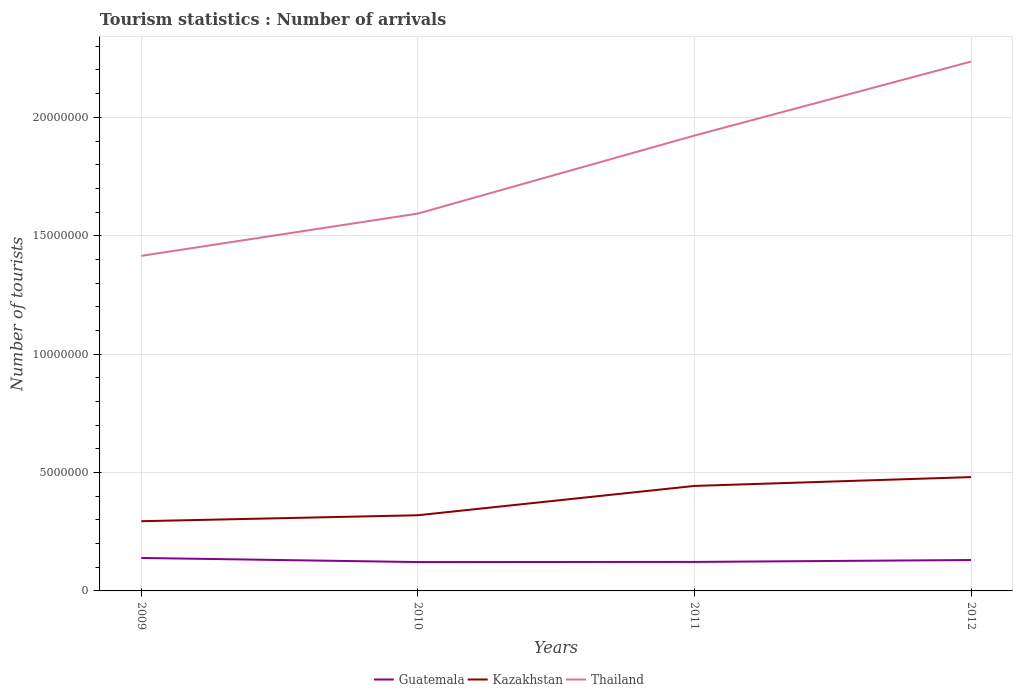How many different coloured lines are there?
Ensure brevity in your answer.  3. Is the number of lines equal to the number of legend labels?
Your answer should be very brief. Yes. Across all years, what is the maximum number of tourist arrivals in Kazakhstan?
Offer a terse response. 2.94e+06. What is the total number of tourist arrivals in Guatemala in the graph?
Provide a succinct answer. -6000. What is the difference between the highest and the second highest number of tourist arrivals in Guatemala?
Ensure brevity in your answer.  1.73e+05. What is the difference between the highest and the lowest number of tourist arrivals in Guatemala?
Your answer should be compact. 2. Is the number of tourist arrivals in Guatemala strictly greater than the number of tourist arrivals in Thailand over the years?
Your answer should be compact. Yes. How many lines are there?
Your answer should be compact. 3. What is the difference between two consecutive major ticks on the Y-axis?
Make the answer very short. 5.00e+06. Are the values on the major ticks of Y-axis written in scientific E-notation?
Your answer should be very brief. No. Does the graph contain any zero values?
Your answer should be compact. No. How many legend labels are there?
Your answer should be compact. 3. What is the title of the graph?
Provide a succinct answer. Tourism statistics : Number of arrivals. What is the label or title of the Y-axis?
Provide a succinct answer. Number of tourists. What is the Number of tourists of Guatemala in 2009?
Your response must be concise. 1.39e+06. What is the Number of tourists in Kazakhstan in 2009?
Make the answer very short. 2.94e+06. What is the Number of tourists in Thailand in 2009?
Offer a terse response. 1.42e+07. What is the Number of tourists of Guatemala in 2010?
Your answer should be compact. 1.22e+06. What is the Number of tourists in Kazakhstan in 2010?
Provide a succinct answer. 3.20e+06. What is the Number of tourists of Thailand in 2010?
Make the answer very short. 1.59e+07. What is the Number of tourists of Guatemala in 2011?
Your response must be concise. 1.22e+06. What is the Number of tourists of Kazakhstan in 2011?
Your answer should be compact. 4.43e+06. What is the Number of tourists in Thailand in 2011?
Your answer should be compact. 1.92e+07. What is the Number of tourists of Guatemala in 2012?
Provide a succinct answer. 1.30e+06. What is the Number of tourists of Kazakhstan in 2012?
Offer a terse response. 4.81e+06. What is the Number of tourists of Thailand in 2012?
Offer a terse response. 2.24e+07. Across all years, what is the maximum Number of tourists of Guatemala?
Offer a terse response. 1.39e+06. Across all years, what is the maximum Number of tourists of Kazakhstan?
Make the answer very short. 4.81e+06. Across all years, what is the maximum Number of tourists of Thailand?
Provide a short and direct response. 2.24e+07. Across all years, what is the minimum Number of tourists in Guatemala?
Offer a terse response. 1.22e+06. Across all years, what is the minimum Number of tourists of Kazakhstan?
Your answer should be compact. 2.94e+06. Across all years, what is the minimum Number of tourists in Thailand?
Offer a very short reply. 1.42e+07. What is the total Number of tourists of Guatemala in the graph?
Ensure brevity in your answer.  5.14e+06. What is the total Number of tourists in Kazakhstan in the graph?
Give a very brief answer. 1.54e+07. What is the total Number of tourists in Thailand in the graph?
Your answer should be very brief. 7.17e+07. What is the difference between the Number of tourists of Guatemala in 2009 and that in 2010?
Provide a short and direct response. 1.73e+05. What is the difference between the Number of tourists in Kazakhstan in 2009 and that in 2010?
Ensure brevity in your answer.  -2.52e+05. What is the difference between the Number of tourists in Thailand in 2009 and that in 2010?
Provide a succinct answer. -1.79e+06. What is the difference between the Number of tourists in Guatemala in 2009 and that in 2011?
Ensure brevity in your answer.  1.67e+05. What is the difference between the Number of tourists in Kazakhstan in 2009 and that in 2011?
Give a very brief answer. -1.49e+06. What is the difference between the Number of tourists in Thailand in 2009 and that in 2011?
Provide a succinct answer. -5.08e+06. What is the difference between the Number of tourists of Guatemala in 2009 and that in 2012?
Offer a very short reply. 8.70e+04. What is the difference between the Number of tourists in Kazakhstan in 2009 and that in 2012?
Keep it short and to the point. -1.86e+06. What is the difference between the Number of tourists of Thailand in 2009 and that in 2012?
Offer a terse response. -8.20e+06. What is the difference between the Number of tourists of Guatemala in 2010 and that in 2011?
Your answer should be compact. -6000. What is the difference between the Number of tourists in Kazakhstan in 2010 and that in 2011?
Provide a succinct answer. -1.24e+06. What is the difference between the Number of tourists in Thailand in 2010 and that in 2011?
Provide a succinct answer. -3.29e+06. What is the difference between the Number of tourists in Guatemala in 2010 and that in 2012?
Make the answer very short. -8.60e+04. What is the difference between the Number of tourists in Kazakhstan in 2010 and that in 2012?
Keep it short and to the point. -1.61e+06. What is the difference between the Number of tourists in Thailand in 2010 and that in 2012?
Ensure brevity in your answer.  -6.42e+06. What is the difference between the Number of tourists of Kazakhstan in 2011 and that in 2012?
Your answer should be compact. -3.73e+05. What is the difference between the Number of tourists in Thailand in 2011 and that in 2012?
Your response must be concise. -3.12e+06. What is the difference between the Number of tourists of Guatemala in 2009 and the Number of tourists of Kazakhstan in 2010?
Your response must be concise. -1.80e+06. What is the difference between the Number of tourists of Guatemala in 2009 and the Number of tourists of Thailand in 2010?
Provide a succinct answer. -1.45e+07. What is the difference between the Number of tourists in Kazakhstan in 2009 and the Number of tourists in Thailand in 2010?
Ensure brevity in your answer.  -1.30e+07. What is the difference between the Number of tourists of Guatemala in 2009 and the Number of tourists of Kazakhstan in 2011?
Give a very brief answer. -3.04e+06. What is the difference between the Number of tourists in Guatemala in 2009 and the Number of tourists in Thailand in 2011?
Your answer should be very brief. -1.78e+07. What is the difference between the Number of tourists in Kazakhstan in 2009 and the Number of tourists in Thailand in 2011?
Your answer should be very brief. -1.63e+07. What is the difference between the Number of tourists of Guatemala in 2009 and the Number of tourists of Kazakhstan in 2012?
Offer a very short reply. -3.42e+06. What is the difference between the Number of tourists in Guatemala in 2009 and the Number of tourists in Thailand in 2012?
Offer a terse response. -2.10e+07. What is the difference between the Number of tourists in Kazakhstan in 2009 and the Number of tourists in Thailand in 2012?
Your response must be concise. -1.94e+07. What is the difference between the Number of tourists of Guatemala in 2010 and the Number of tourists of Kazakhstan in 2011?
Make the answer very short. -3.22e+06. What is the difference between the Number of tourists in Guatemala in 2010 and the Number of tourists in Thailand in 2011?
Your answer should be very brief. -1.80e+07. What is the difference between the Number of tourists in Kazakhstan in 2010 and the Number of tourists in Thailand in 2011?
Offer a terse response. -1.60e+07. What is the difference between the Number of tourists of Guatemala in 2010 and the Number of tourists of Kazakhstan in 2012?
Give a very brief answer. -3.59e+06. What is the difference between the Number of tourists of Guatemala in 2010 and the Number of tourists of Thailand in 2012?
Provide a succinct answer. -2.11e+07. What is the difference between the Number of tourists in Kazakhstan in 2010 and the Number of tourists in Thailand in 2012?
Your answer should be very brief. -1.92e+07. What is the difference between the Number of tourists in Guatemala in 2011 and the Number of tourists in Kazakhstan in 2012?
Offer a terse response. -3.58e+06. What is the difference between the Number of tourists of Guatemala in 2011 and the Number of tourists of Thailand in 2012?
Provide a short and direct response. -2.11e+07. What is the difference between the Number of tourists in Kazakhstan in 2011 and the Number of tourists in Thailand in 2012?
Keep it short and to the point. -1.79e+07. What is the average Number of tourists in Guatemala per year?
Give a very brief answer. 1.29e+06. What is the average Number of tourists of Kazakhstan per year?
Ensure brevity in your answer.  3.85e+06. What is the average Number of tourists of Thailand per year?
Ensure brevity in your answer.  1.79e+07. In the year 2009, what is the difference between the Number of tourists in Guatemala and Number of tourists in Kazakhstan?
Your answer should be compact. -1.55e+06. In the year 2009, what is the difference between the Number of tourists in Guatemala and Number of tourists in Thailand?
Your answer should be very brief. -1.28e+07. In the year 2009, what is the difference between the Number of tourists of Kazakhstan and Number of tourists of Thailand?
Ensure brevity in your answer.  -1.12e+07. In the year 2010, what is the difference between the Number of tourists in Guatemala and Number of tourists in Kazakhstan?
Provide a short and direct response. -1.98e+06. In the year 2010, what is the difference between the Number of tourists in Guatemala and Number of tourists in Thailand?
Provide a succinct answer. -1.47e+07. In the year 2010, what is the difference between the Number of tourists in Kazakhstan and Number of tourists in Thailand?
Make the answer very short. -1.27e+07. In the year 2011, what is the difference between the Number of tourists in Guatemala and Number of tourists in Kazakhstan?
Your response must be concise. -3.21e+06. In the year 2011, what is the difference between the Number of tourists in Guatemala and Number of tourists in Thailand?
Offer a very short reply. -1.80e+07. In the year 2011, what is the difference between the Number of tourists in Kazakhstan and Number of tourists in Thailand?
Your response must be concise. -1.48e+07. In the year 2012, what is the difference between the Number of tourists in Guatemala and Number of tourists in Kazakhstan?
Keep it short and to the point. -3.50e+06. In the year 2012, what is the difference between the Number of tourists in Guatemala and Number of tourists in Thailand?
Offer a terse response. -2.10e+07. In the year 2012, what is the difference between the Number of tourists in Kazakhstan and Number of tourists in Thailand?
Give a very brief answer. -1.75e+07. What is the ratio of the Number of tourists of Guatemala in 2009 to that in 2010?
Offer a terse response. 1.14. What is the ratio of the Number of tourists of Kazakhstan in 2009 to that in 2010?
Provide a succinct answer. 0.92. What is the ratio of the Number of tourists in Thailand in 2009 to that in 2010?
Offer a terse response. 0.89. What is the ratio of the Number of tourists in Guatemala in 2009 to that in 2011?
Provide a succinct answer. 1.14. What is the ratio of the Number of tourists of Kazakhstan in 2009 to that in 2011?
Your answer should be very brief. 0.66. What is the ratio of the Number of tourists of Thailand in 2009 to that in 2011?
Your answer should be very brief. 0.74. What is the ratio of the Number of tourists of Guatemala in 2009 to that in 2012?
Your answer should be very brief. 1.07. What is the ratio of the Number of tourists in Kazakhstan in 2009 to that in 2012?
Your answer should be very brief. 0.61. What is the ratio of the Number of tourists of Thailand in 2009 to that in 2012?
Keep it short and to the point. 0.63. What is the ratio of the Number of tourists in Kazakhstan in 2010 to that in 2011?
Your answer should be compact. 0.72. What is the ratio of the Number of tourists of Thailand in 2010 to that in 2011?
Keep it short and to the point. 0.83. What is the ratio of the Number of tourists in Guatemala in 2010 to that in 2012?
Your answer should be compact. 0.93. What is the ratio of the Number of tourists in Kazakhstan in 2010 to that in 2012?
Make the answer very short. 0.66. What is the ratio of the Number of tourists in Thailand in 2010 to that in 2012?
Provide a succinct answer. 0.71. What is the ratio of the Number of tourists of Guatemala in 2011 to that in 2012?
Provide a short and direct response. 0.94. What is the ratio of the Number of tourists in Kazakhstan in 2011 to that in 2012?
Offer a very short reply. 0.92. What is the ratio of the Number of tourists in Thailand in 2011 to that in 2012?
Your response must be concise. 0.86. What is the difference between the highest and the second highest Number of tourists of Guatemala?
Provide a succinct answer. 8.70e+04. What is the difference between the highest and the second highest Number of tourists of Kazakhstan?
Give a very brief answer. 3.73e+05. What is the difference between the highest and the second highest Number of tourists in Thailand?
Offer a terse response. 3.12e+06. What is the difference between the highest and the lowest Number of tourists in Guatemala?
Your answer should be compact. 1.73e+05. What is the difference between the highest and the lowest Number of tourists of Kazakhstan?
Provide a succinct answer. 1.86e+06. What is the difference between the highest and the lowest Number of tourists of Thailand?
Offer a very short reply. 8.20e+06. 